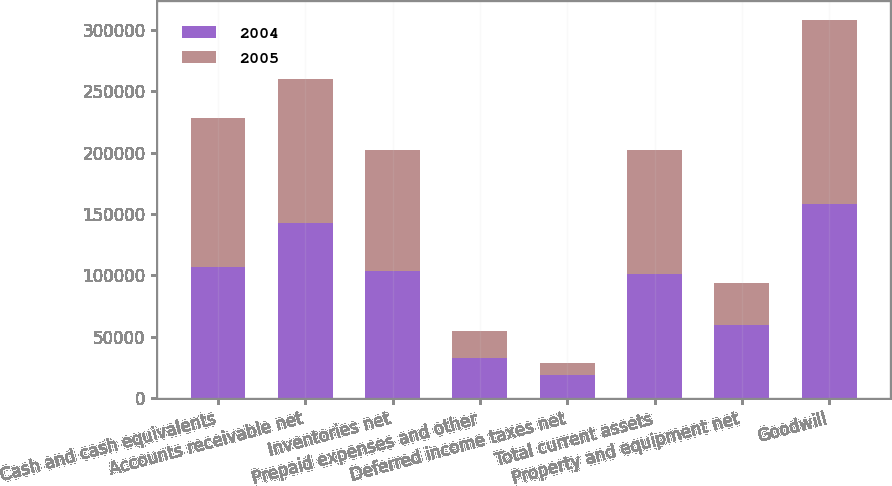<chart> <loc_0><loc_0><loc_500><loc_500><stacked_bar_chart><ecel><fcel>Cash and cash equivalents<fcel>Accounts receivable net<fcel>Inventories net<fcel>Prepaid expenses and other<fcel>Deferred income taxes net<fcel>Total current assets<fcel>Property and equipment net<fcel>Goodwill<nl><fcel>2004<fcel>107057<fcel>142782<fcel>103837<fcel>33153<fcel>18709<fcel>101048<fcel>59479<fcel>158065<nl><fcel>2005<fcel>120692<fcel>116928<fcel>98258<fcel>21769<fcel>9771<fcel>101048<fcel>34778<fcel>149475<nl></chart> 